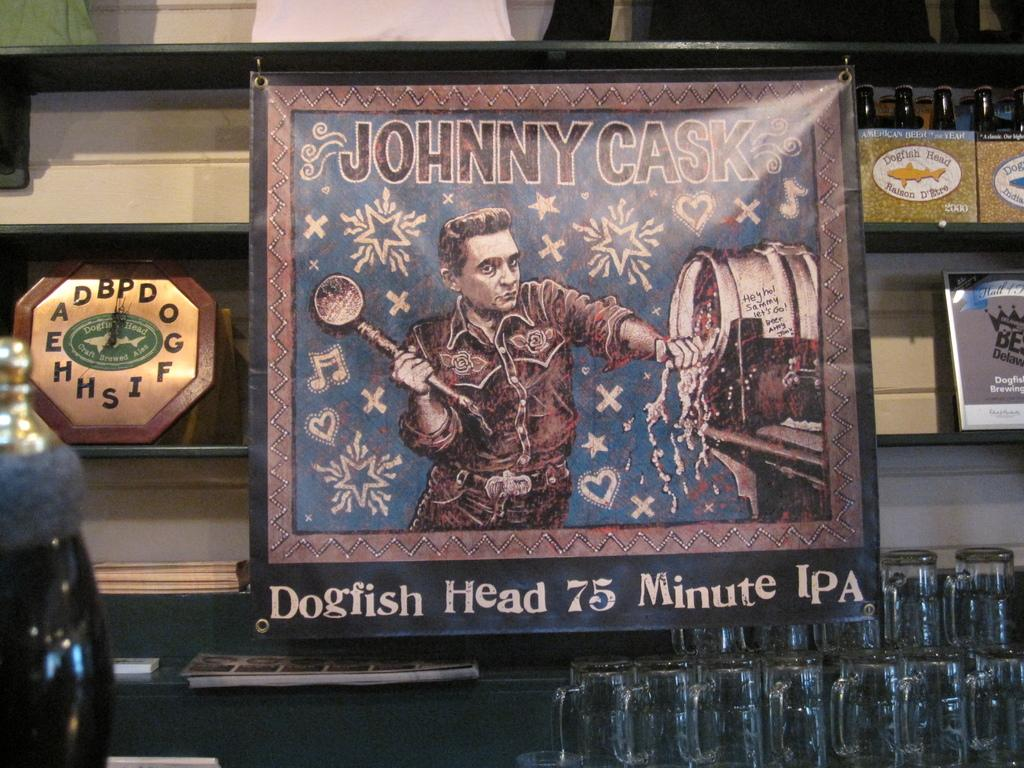<image>
Create a compact narrative representing the image presented. A picture that says Johnny Cask and has a picture of Johnny Cash pouring out a keg. 